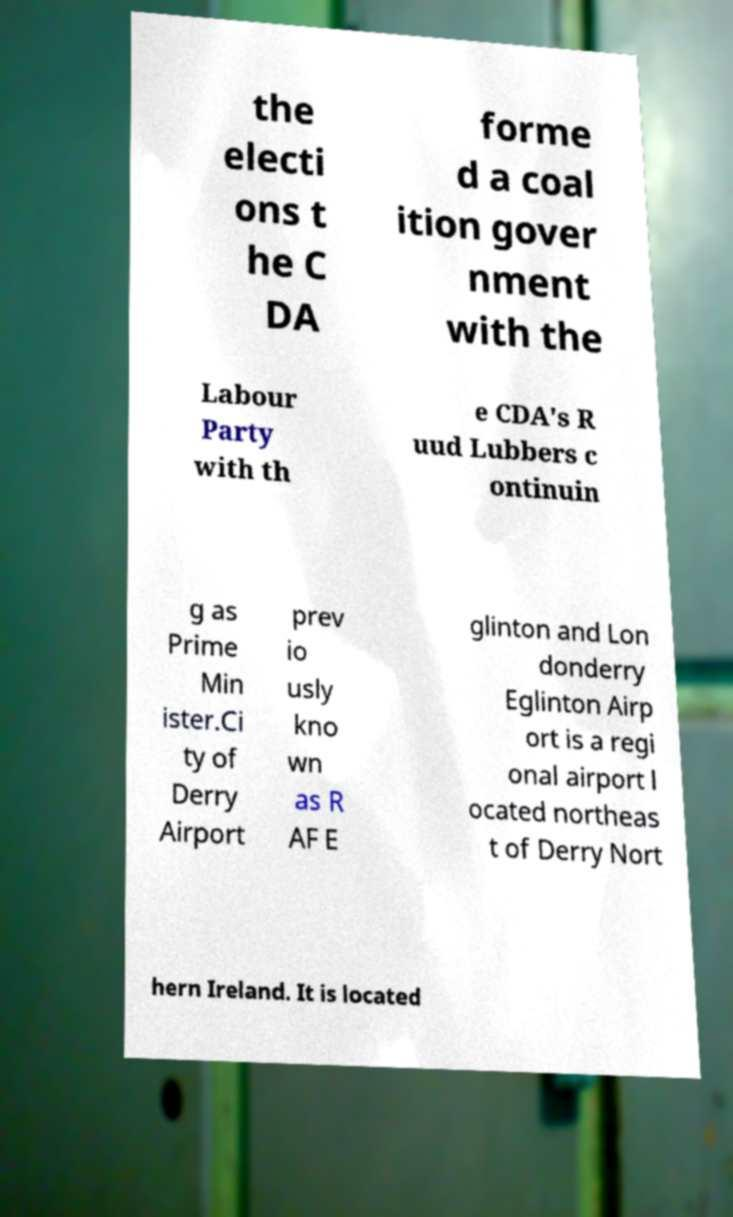For documentation purposes, I need the text within this image transcribed. Could you provide that? the electi ons t he C DA forme d a coal ition gover nment with the Labour Party with th e CDA's R uud Lubbers c ontinuin g as Prime Min ister.Ci ty of Derry Airport prev io usly kno wn as R AF E glinton and Lon donderry Eglinton Airp ort is a regi onal airport l ocated northeas t of Derry Nort hern Ireland. It is located 